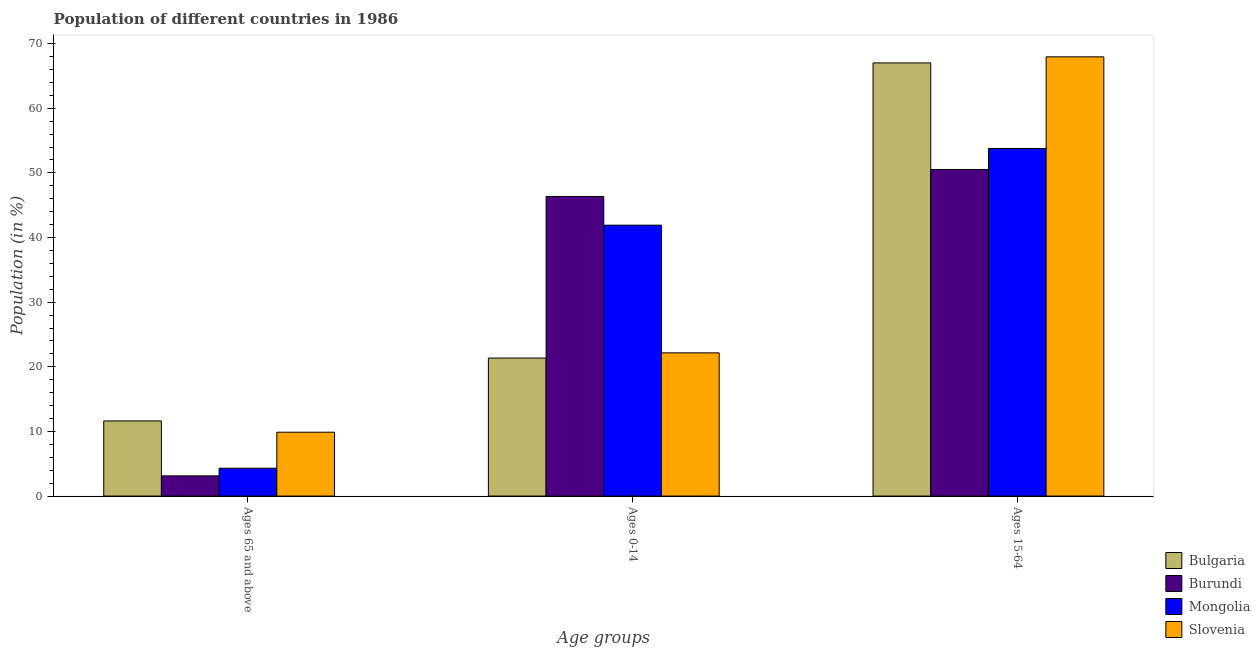How many different coloured bars are there?
Give a very brief answer. 4. Are the number of bars on each tick of the X-axis equal?
Offer a terse response. Yes. How many bars are there on the 1st tick from the right?
Provide a succinct answer. 4. What is the label of the 2nd group of bars from the left?
Provide a short and direct response. Ages 0-14. What is the percentage of population within the age-group 15-64 in Bulgaria?
Your answer should be very brief. 67.02. Across all countries, what is the maximum percentage of population within the age-group 0-14?
Give a very brief answer. 46.36. Across all countries, what is the minimum percentage of population within the age-group 15-64?
Your response must be concise. 50.52. In which country was the percentage of population within the age-group of 65 and above minimum?
Keep it short and to the point. Burundi. What is the total percentage of population within the age-group 15-64 in the graph?
Keep it short and to the point. 239.27. What is the difference between the percentage of population within the age-group 15-64 in Mongolia and that in Slovenia?
Make the answer very short. -14.18. What is the difference between the percentage of population within the age-group 0-14 in Mongolia and the percentage of population within the age-group 15-64 in Bulgaria?
Your answer should be very brief. -25.1. What is the average percentage of population within the age-group 0-14 per country?
Provide a short and direct response. 32.95. What is the difference between the percentage of population within the age-group 0-14 and percentage of population within the age-group 15-64 in Mongolia?
Your answer should be very brief. -11.86. In how many countries, is the percentage of population within the age-group 0-14 greater than 2 %?
Your response must be concise. 4. What is the ratio of the percentage of population within the age-group of 65 and above in Bulgaria to that in Burundi?
Keep it short and to the point. 3.72. What is the difference between the highest and the second highest percentage of population within the age-group 15-64?
Offer a terse response. 0.94. What is the difference between the highest and the lowest percentage of population within the age-group 15-64?
Your answer should be compact. 17.44. In how many countries, is the percentage of population within the age-group 0-14 greater than the average percentage of population within the age-group 0-14 taken over all countries?
Your answer should be compact. 2. What does the 3rd bar from the left in Ages 0-14 represents?
Make the answer very short. Mongolia. What does the 3rd bar from the right in Ages 0-14 represents?
Your response must be concise. Burundi. Is it the case that in every country, the sum of the percentage of population within the age-group of 65 and above and percentage of population within the age-group 0-14 is greater than the percentage of population within the age-group 15-64?
Keep it short and to the point. No. Are all the bars in the graph horizontal?
Provide a short and direct response. No. What is the difference between two consecutive major ticks on the Y-axis?
Provide a succinct answer. 10. Are the values on the major ticks of Y-axis written in scientific E-notation?
Provide a succinct answer. No. How many legend labels are there?
Ensure brevity in your answer.  4. How are the legend labels stacked?
Offer a terse response. Vertical. What is the title of the graph?
Make the answer very short. Population of different countries in 1986. What is the label or title of the X-axis?
Your answer should be compact. Age groups. What is the Population (in %) of Bulgaria in Ages 65 and above?
Offer a terse response. 11.62. What is the Population (in %) of Burundi in Ages 65 and above?
Keep it short and to the point. 3.12. What is the Population (in %) in Mongolia in Ages 65 and above?
Provide a succinct answer. 4.31. What is the Population (in %) of Slovenia in Ages 65 and above?
Your answer should be very brief. 9.88. What is the Population (in %) in Bulgaria in Ages 0-14?
Make the answer very short. 21.36. What is the Population (in %) of Burundi in Ages 0-14?
Make the answer very short. 46.36. What is the Population (in %) of Mongolia in Ages 0-14?
Your response must be concise. 41.92. What is the Population (in %) in Slovenia in Ages 0-14?
Give a very brief answer. 22.16. What is the Population (in %) of Bulgaria in Ages 15-64?
Offer a terse response. 67.02. What is the Population (in %) in Burundi in Ages 15-64?
Offer a very short reply. 50.52. What is the Population (in %) in Mongolia in Ages 15-64?
Your answer should be compact. 53.77. What is the Population (in %) in Slovenia in Ages 15-64?
Make the answer very short. 67.96. Across all Age groups, what is the maximum Population (in %) of Bulgaria?
Your answer should be compact. 67.02. Across all Age groups, what is the maximum Population (in %) in Burundi?
Your answer should be very brief. 50.52. Across all Age groups, what is the maximum Population (in %) in Mongolia?
Offer a terse response. 53.77. Across all Age groups, what is the maximum Population (in %) of Slovenia?
Keep it short and to the point. 67.96. Across all Age groups, what is the minimum Population (in %) of Bulgaria?
Provide a succinct answer. 11.62. Across all Age groups, what is the minimum Population (in %) of Burundi?
Your answer should be very brief. 3.12. Across all Age groups, what is the minimum Population (in %) of Mongolia?
Give a very brief answer. 4.31. Across all Age groups, what is the minimum Population (in %) in Slovenia?
Offer a terse response. 9.88. What is the total Population (in %) in Bulgaria in the graph?
Keep it short and to the point. 100. What is the total Population (in %) of Burundi in the graph?
Your answer should be very brief. 100. What is the total Population (in %) of Slovenia in the graph?
Make the answer very short. 100. What is the difference between the Population (in %) in Bulgaria in Ages 65 and above and that in Ages 0-14?
Offer a terse response. -9.73. What is the difference between the Population (in %) of Burundi in Ages 65 and above and that in Ages 0-14?
Provide a short and direct response. -43.23. What is the difference between the Population (in %) in Mongolia in Ages 65 and above and that in Ages 0-14?
Provide a short and direct response. -37.61. What is the difference between the Population (in %) of Slovenia in Ages 65 and above and that in Ages 0-14?
Provide a succinct answer. -12.28. What is the difference between the Population (in %) of Bulgaria in Ages 65 and above and that in Ages 15-64?
Keep it short and to the point. -55.4. What is the difference between the Population (in %) of Burundi in Ages 65 and above and that in Ages 15-64?
Keep it short and to the point. -47.4. What is the difference between the Population (in %) in Mongolia in Ages 65 and above and that in Ages 15-64?
Keep it short and to the point. -49.47. What is the difference between the Population (in %) of Slovenia in Ages 65 and above and that in Ages 15-64?
Your answer should be very brief. -58.08. What is the difference between the Population (in %) in Bulgaria in Ages 0-14 and that in Ages 15-64?
Ensure brevity in your answer.  -45.66. What is the difference between the Population (in %) of Burundi in Ages 0-14 and that in Ages 15-64?
Your answer should be compact. -4.16. What is the difference between the Population (in %) in Mongolia in Ages 0-14 and that in Ages 15-64?
Keep it short and to the point. -11.86. What is the difference between the Population (in %) of Slovenia in Ages 0-14 and that in Ages 15-64?
Give a very brief answer. -45.8. What is the difference between the Population (in %) of Bulgaria in Ages 65 and above and the Population (in %) of Burundi in Ages 0-14?
Provide a short and direct response. -34.73. What is the difference between the Population (in %) of Bulgaria in Ages 65 and above and the Population (in %) of Mongolia in Ages 0-14?
Your answer should be very brief. -30.29. What is the difference between the Population (in %) of Bulgaria in Ages 65 and above and the Population (in %) of Slovenia in Ages 0-14?
Your answer should be compact. -10.54. What is the difference between the Population (in %) in Burundi in Ages 65 and above and the Population (in %) in Mongolia in Ages 0-14?
Offer a very short reply. -38.79. What is the difference between the Population (in %) of Burundi in Ages 65 and above and the Population (in %) of Slovenia in Ages 0-14?
Give a very brief answer. -19.04. What is the difference between the Population (in %) in Mongolia in Ages 65 and above and the Population (in %) in Slovenia in Ages 0-14?
Give a very brief answer. -17.85. What is the difference between the Population (in %) in Bulgaria in Ages 65 and above and the Population (in %) in Burundi in Ages 15-64?
Offer a terse response. -38.9. What is the difference between the Population (in %) of Bulgaria in Ages 65 and above and the Population (in %) of Mongolia in Ages 15-64?
Your answer should be compact. -42.15. What is the difference between the Population (in %) in Bulgaria in Ages 65 and above and the Population (in %) in Slovenia in Ages 15-64?
Provide a succinct answer. -56.34. What is the difference between the Population (in %) of Burundi in Ages 65 and above and the Population (in %) of Mongolia in Ages 15-64?
Your response must be concise. -50.65. What is the difference between the Population (in %) in Burundi in Ages 65 and above and the Population (in %) in Slovenia in Ages 15-64?
Make the answer very short. -64.84. What is the difference between the Population (in %) in Mongolia in Ages 65 and above and the Population (in %) in Slovenia in Ages 15-64?
Your answer should be compact. -63.65. What is the difference between the Population (in %) in Bulgaria in Ages 0-14 and the Population (in %) in Burundi in Ages 15-64?
Your answer should be compact. -29.16. What is the difference between the Population (in %) of Bulgaria in Ages 0-14 and the Population (in %) of Mongolia in Ages 15-64?
Provide a succinct answer. -32.42. What is the difference between the Population (in %) in Bulgaria in Ages 0-14 and the Population (in %) in Slovenia in Ages 15-64?
Your response must be concise. -46.6. What is the difference between the Population (in %) in Burundi in Ages 0-14 and the Population (in %) in Mongolia in Ages 15-64?
Make the answer very short. -7.42. What is the difference between the Population (in %) of Burundi in Ages 0-14 and the Population (in %) of Slovenia in Ages 15-64?
Make the answer very short. -21.6. What is the difference between the Population (in %) of Mongolia in Ages 0-14 and the Population (in %) of Slovenia in Ages 15-64?
Offer a terse response. -26.04. What is the average Population (in %) of Bulgaria per Age groups?
Your response must be concise. 33.33. What is the average Population (in %) in Burundi per Age groups?
Your response must be concise. 33.33. What is the average Population (in %) in Mongolia per Age groups?
Your answer should be very brief. 33.33. What is the average Population (in %) of Slovenia per Age groups?
Ensure brevity in your answer.  33.33. What is the difference between the Population (in %) of Bulgaria and Population (in %) of Burundi in Ages 65 and above?
Offer a terse response. 8.5. What is the difference between the Population (in %) in Bulgaria and Population (in %) in Mongolia in Ages 65 and above?
Give a very brief answer. 7.31. What is the difference between the Population (in %) of Bulgaria and Population (in %) of Slovenia in Ages 65 and above?
Ensure brevity in your answer.  1.74. What is the difference between the Population (in %) in Burundi and Population (in %) in Mongolia in Ages 65 and above?
Keep it short and to the point. -1.19. What is the difference between the Population (in %) in Burundi and Population (in %) in Slovenia in Ages 65 and above?
Your answer should be compact. -6.76. What is the difference between the Population (in %) of Mongolia and Population (in %) of Slovenia in Ages 65 and above?
Offer a very short reply. -5.57. What is the difference between the Population (in %) in Bulgaria and Population (in %) in Burundi in Ages 0-14?
Offer a very short reply. -25. What is the difference between the Population (in %) in Bulgaria and Population (in %) in Mongolia in Ages 0-14?
Give a very brief answer. -20.56. What is the difference between the Population (in %) in Bulgaria and Population (in %) in Slovenia in Ages 0-14?
Keep it short and to the point. -0.8. What is the difference between the Population (in %) of Burundi and Population (in %) of Mongolia in Ages 0-14?
Offer a terse response. 4.44. What is the difference between the Population (in %) of Burundi and Population (in %) of Slovenia in Ages 0-14?
Ensure brevity in your answer.  24.2. What is the difference between the Population (in %) in Mongolia and Population (in %) in Slovenia in Ages 0-14?
Give a very brief answer. 19.76. What is the difference between the Population (in %) in Bulgaria and Population (in %) in Burundi in Ages 15-64?
Keep it short and to the point. 16.5. What is the difference between the Population (in %) of Bulgaria and Population (in %) of Mongolia in Ages 15-64?
Provide a short and direct response. 13.25. What is the difference between the Population (in %) in Bulgaria and Population (in %) in Slovenia in Ages 15-64?
Ensure brevity in your answer.  -0.94. What is the difference between the Population (in %) in Burundi and Population (in %) in Mongolia in Ages 15-64?
Provide a succinct answer. -3.26. What is the difference between the Population (in %) of Burundi and Population (in %) of Slovenia in Ages 15-64?
Provide a short and direct response. -17.44. What is the difference between the Population (in %) of Mongolia and Population (in %) of Slovenia in Ages 15-64?
Your answer should be compact. -14.18. What is the ratio of the Population (in %) in Bulgaria in Ages 65 and above to that in Ages 0-14?
Ensure brevity in your answer.  0.54. What is the ratio of the Population (in %) of Burundi in Ages 65 and above to that in Ages 0-14?
Ensure brevity in your answer.  0.07. What is the ratio of the Population (in %) in Mongolia in Ages 65 and above to that in Ages 0-14?
Your answer should be compact. 0.1. What is the ratio of the Population (in %) of Slovenia in Ages 65 and above to that in Ages 0-14?
Keep it short and to the point. 0.45. What is the ratio of the Population (in %) of Bulgaria in Ages 65 and above to that in Ages 15-64?
Provide a succinct answer. 0.17. What is the ratio of the Population (in %) of Burundi in Ages 65 and above to that in Ages 15-64?
Provide a short and direct response. 0.06. What is the ratio of the Population (in %) of Mongolia in Ages 65 and above to that in Ages 15-64?
Your answer should be compact. 0.08. What is the ratio of the Population (in %) of Slovenia in Ages 65 and above to that in Ages 15-64?
Offer a very short reply. 0.15. What is the ratio of the Population (in %) of Bulgaria in Ages 0-14 to that in Ages 15-64?
Your answer should be compact. 0.32. What is the ratio of the Population (in %) in Burundi in Ages 0-14 to that in Ages 15-64?
Provide a short and direct response. 0.92. What is the ratio of the Population (in %) in Mongolia in Ages 0-14 to that in Ages 15-64?
Provide a succinct answer. 0.78. What is the ratio of the Population (in %) in Slovenia in Ages 0-14 to that in Ages 15-64?
Provide a short and direct response. 0.33. What is the difference between the highest and the second highest Population (in %) of Bulgaria?
Your answer should be compact. 45.66. What is the difference between the highest and the second highest Population (in %) in Burundi?
Your response must be concise. 4.16. What is the difference between the highest and the second highest Population (in %) in Mongolia?
Your answer should be compact. 11.86. What is the difference between the highest and the second highest Population (in %) in Slovenia?
Your answer should be very brief. 45.8. What is the difference between the highest and the lowest Population (in %) of Bulgaria?
Keep it short and to the point. 55.4. What is the difference between the highest and the lowest Population (in %) in Burundi?
Keep it short and to the point. 47.4. What is the difference between the highest and the lowest Population (in %) in Mongolia?
Give a very brief answer. 49.47. What is the difference between the highest and the lowest Population (in %) of Slovenia?
Your answer should be compact. 58.08. 